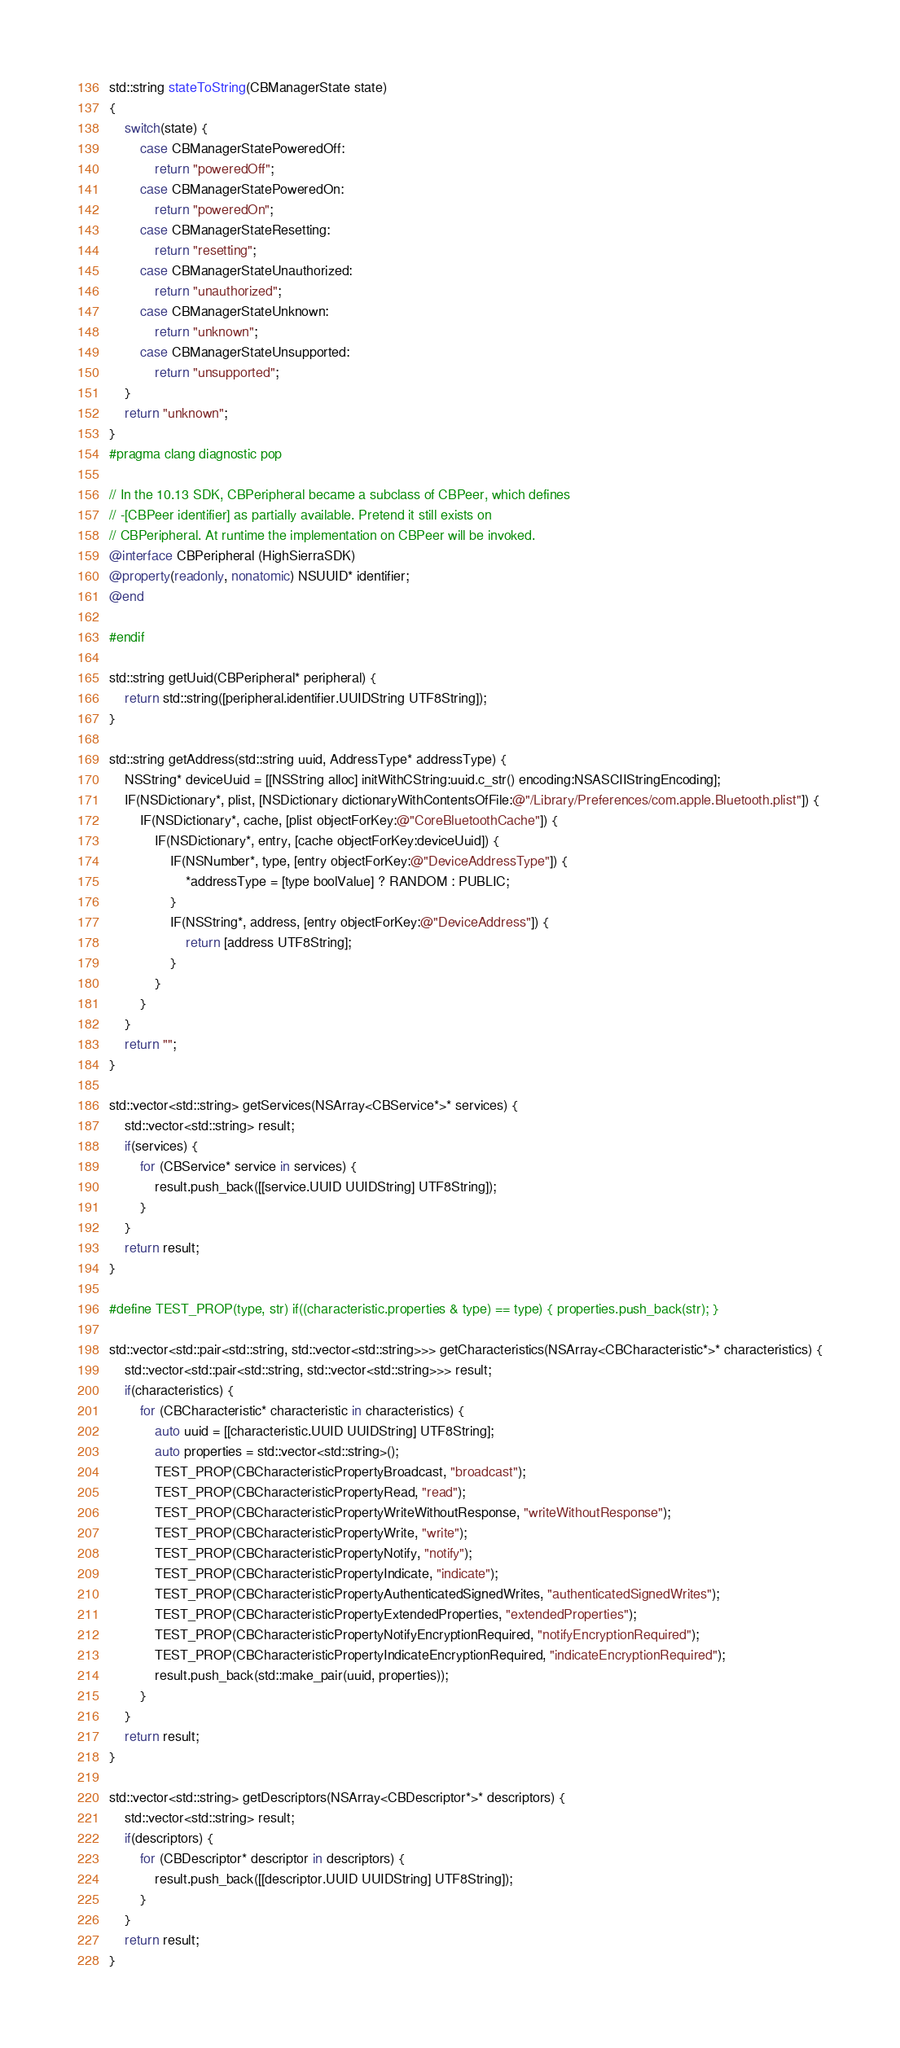Convert code to text. <code><loc_0><loc_0><loc_500><loc_500><_ObjectiveC_>std::string stateToString(CBManagerState state)
{
    switch(state) {
        case CBManagerStatePoweredOff:
            return "poweredOff";
        case CBManagerStatePoweredOn:
            return "poweredOn";
        case CBManagerStateResetting:
            return "resetting";
        case CBManagerStateUnauthorized:
            return "unauthorized";
        case CBManagerStateUnknown:
            return "unknown";
        case CBManagerStateUnsupported:
            return "unsupported";
    }
    return "unknown";
}
#pragma clang diagnostic pop

// In the 10.13 SDK, CBPeripheral became a subclass of CBPeer, which defines
// -[CBPeer identifier] as partially available. Pretend it still exists on
// CBPeripheral. At runtime the implementation on CBPeer will be invoked.
@interface CBPeripheral (HighSierraSDK)
@property(readonly, nonatomic) NSUUID* identifier;
@end

#endif

std::string getUuid(CBPeripheral* peripheral) {
    return std::string([peripheral.identifier.UUIDString UTF8String]);
}

std::string getAddress(std::string uuid, AddressType* addressType) {
    NSString* deviceUuid = [[NSString alloc] initWithCString:uuid.c_str() encoding:NSASCIIStringEncoding];
    IF(NSDictionary*, plist, [NSDictionary dictionaryWithContentsOfFile:@"/Library/Preferences/com.apple.Bluetooth.plist"]) {
        IF(NSDictionary*, cache, [plist objectForKey:@"CoreBluetoothCache"]) {
            IF(NSDictionary*, entry, [cache objectForKey:deviceUuid]) {
                IF(NSNumber*, type, [entry objectForKey:@"DeviceAddressType"]) {
                    *addressType = [type boolValue] ? RANDOM : PUBLIC;
                }
                IF(NSString*, address, [entry objectForKey:@"DeviceAddress"]) {
                    return [address UTF8String];
                }
            }
        }
    }
    return "";
}

std::vector<std::string> getServices(NSArray<CBService*>* services) {
    std::vector<std::string> result;
    if(services) {
        for (CBService* service in services) {
            result.push_back([[service.UUID UUIDString] UTF8String]);
        }
    }
    return result;
}

#define TEST_PROP(type, str) if((characteristic.properties & type) == type) { properties.push_back(str); }

std::vector<std::pair<std::string, std::vector<std::string>>> getCharacteristics(NSArray<CBCharacteristic*>* characteristics) {
    std::vector<std::pair<std::string, std::vector<std::string>>> result;
    if(characteristics) {
        for (CBCharacteristic* characteristic in characteristics) {
            auto uuid = [[characteristic.UUID UUIDString] UTF8String];
            auto properties = std::vector<std::string>();
            TEST_PROP(CBCharacteristicPropertyBroadcast, "broadcast");
            TEST_PROP(CBCharacteristicPropertyRead, "read");
            TEST_PROP(CBCharacteristicPropertyWriteWithoutResponse, "writeWithoutResponse");
            TEST_PROP(CBCharacteristicPropertyWrite, "write");
            TEST_PROP(CBCharacteristicPropertyNotify, "notify");
            TEST_PROP(CBCharacteristicPropertyIndicate, "indicate");
            TEST_PROP(CBCharacteristicPropertyAuthenticatedSignedWrites, "authenticatedSignedWrites");
            TEST_PROP(CBCharacteristicPropertyExtendedProperties, "extendedProperties");
            TEST_PROP(CBCharacteristicPropertyNotifyEncryptionRequired, "notifyEncryptionRequired");
            TEST_PROP(CBCharacteristicPropertyIndicateEncryptionRequired, "indicateEncryptionRequired");
            result.push_back(std::make_pair(uuid, properties));
        }
    }
    return result;
}

std::vector<std::string> getDescriptors(NSArray<CBDescriptor*>* descriptors) {
    std::vector<std::string> result;
    if(descriptors) {
        for (CBDescriptor* descriptor in descriptors) {
            result.push_back([[descriptor.UUID UUIDString] UTF8String]);
        }
    }
    return result;
}
</code> 